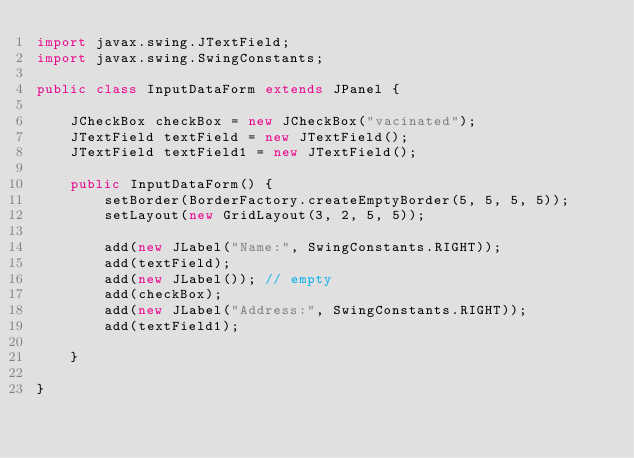Convert code to text. <code><loc_0><loc_0><loc_500><loc_500><_Java_>import javax.swing.JTextField;
import javax.swing.SwingConstants;

public class InputDataForm extends JPanel {

    JCheckBox checkBox = new JCheckBox("vacinated");
    JTextField textField = new JTextField();
    JTextField textField1 = new JTextField();

    public InputDataForm() {
        setBorder(BorderFactory.createEmptyBorder(5, 5, 5, 5));
        setLayout(new GridLayout(3, 2, 5, 5));

        add(new JLabel("Name:", SwingConstants.RIGHT));
        add(textField);
        add(new JLabel()); // empty
        add(checkBox);
        add(new JLabel("Address:", SwingConstants.RIGHT));
        add(textField1);

    }

}
</code> 